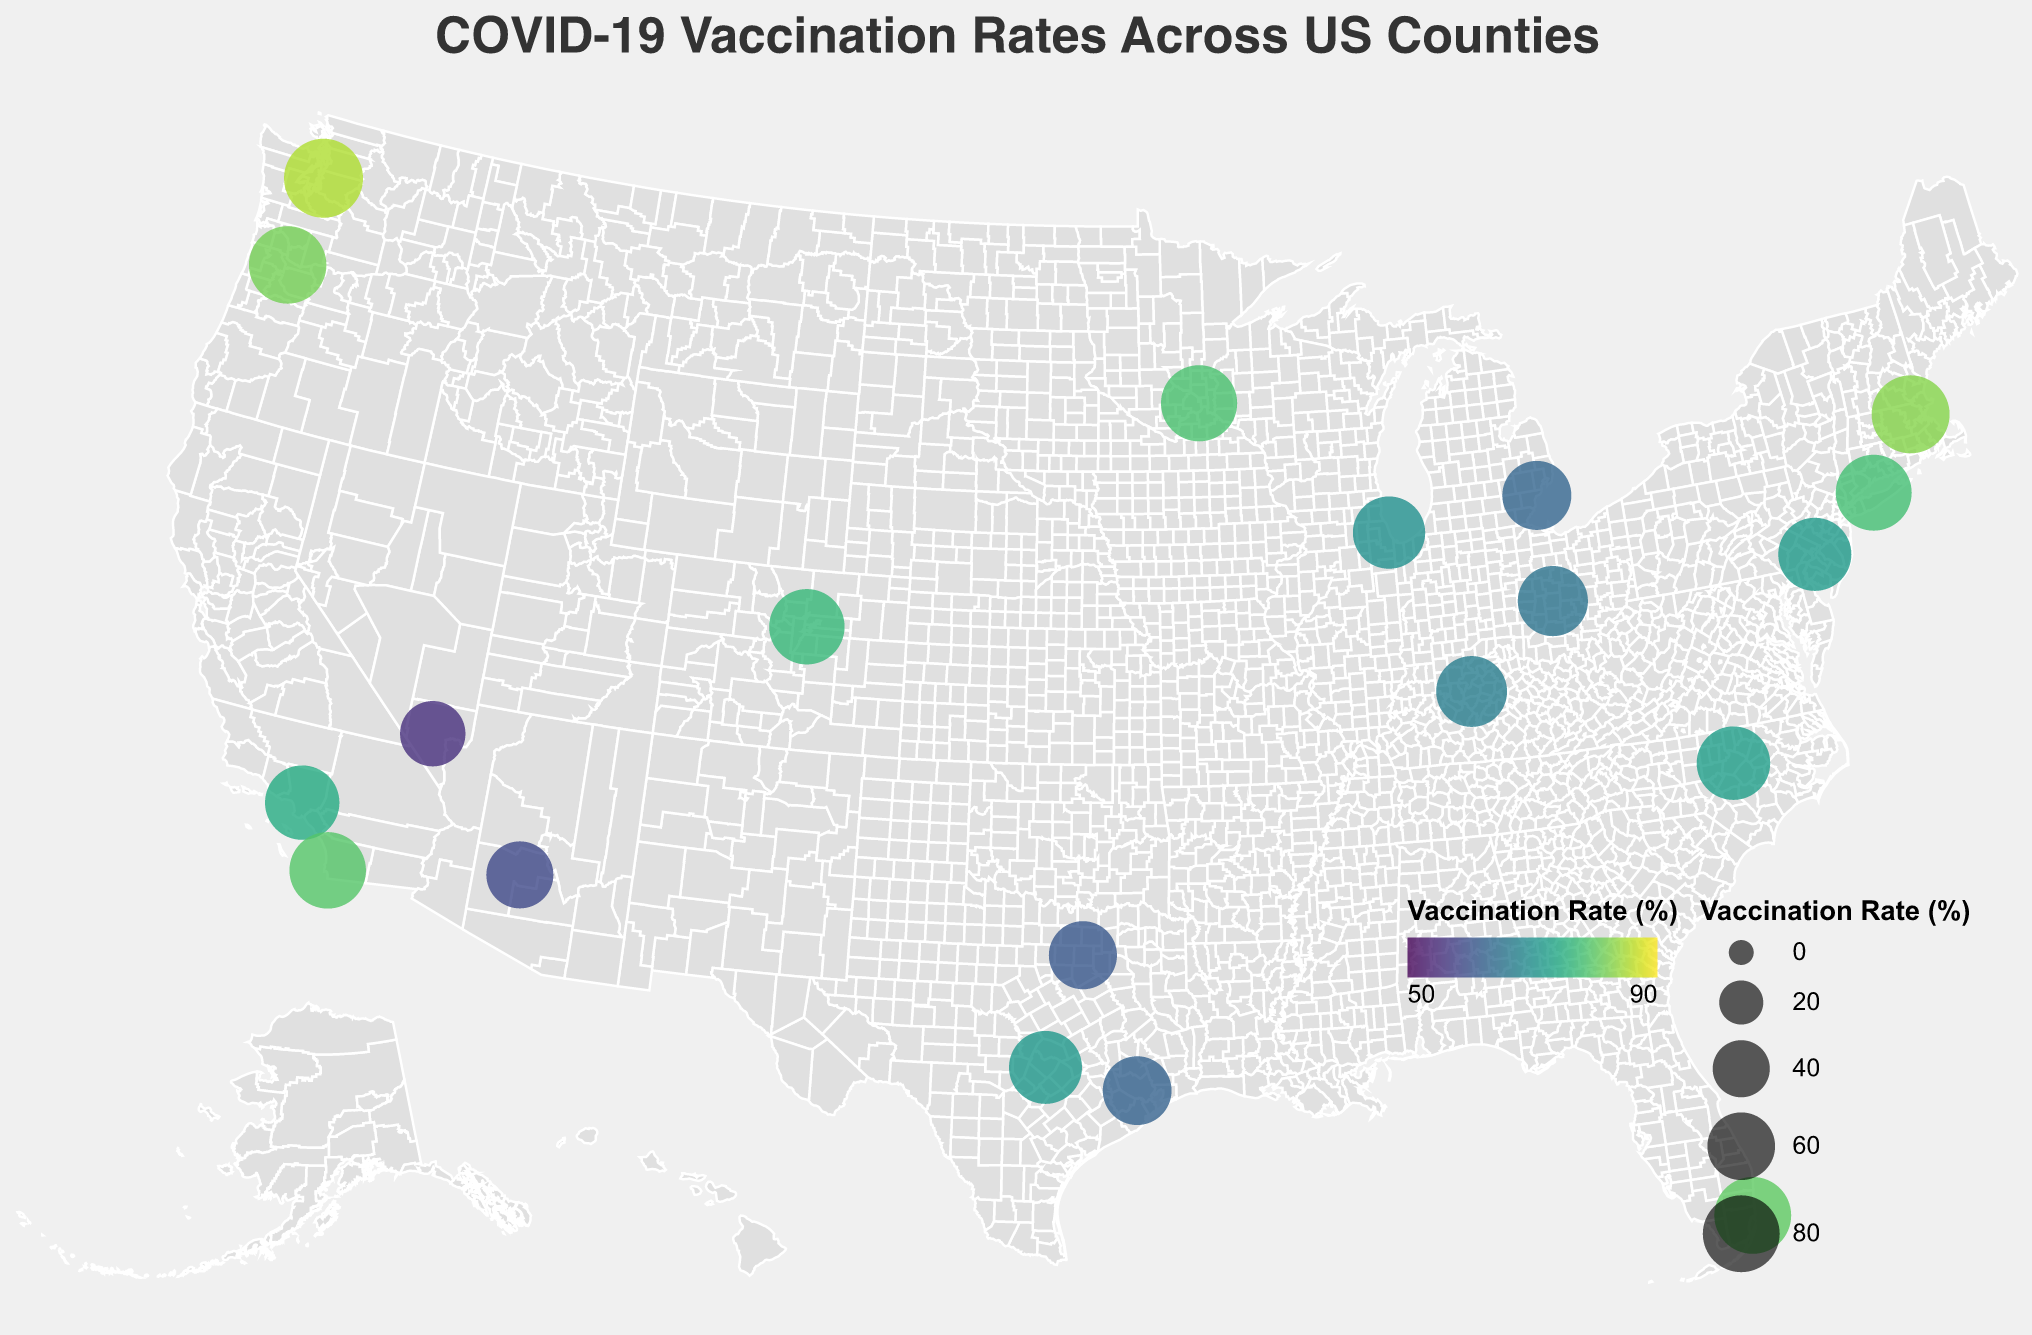What's the title of the figure? The title is usually located at the top of the figure and indicates the main subject. In this case, it is "COVID-19 Vaccination Rates Across US Counties."
Answer: COVID-19 Vaccination Rates Across US Counties Which county has the highest vaccination rate and what is it? By examining the circle sizes and colors, King County in Washington has the largest circle and the darkest color, representing the highest vaccination rate of 85.2%.
Answer: King County, 85.2% What is the vaccination rate of Los Angeles County in California? By locating Los Angeles County on the map and checking its tooltip, the vaccination rate is shown as 74.5%.
Answer: 74.5% How many counties have vaccination rates above 80%? By observing the figure, we note that the counties with darker colors have higher rates. The counties above 80% are King (85.2%), Miami-Dade (80.1%), Middlesex (82.7%), and Multnomah (81.6%).
Answer: 4 What is the vaccination rate difference between Cook County in Illinois and Dallas County in Texas? Cook County's rate is 69.8% and Dallas County's rate is 60.9%. The difference is 69.8% - 60.9% = 8.9%.
Answer: 8.9% Which state has the most counties listed in the figure? By counting the occurrence of different states, Texas has three counties listed: Harris, Dallas, and Travis.
Answer: Texas Which county has the lowest vaccination rate, and what is it? By identifying the smallest and lightest colored circle, Clark County in Nevada has the lowest rate of 55.4%.
Answer: Clark County, 55.4% Compare the vaccination rates of the counties in California. Which one is higher, and by how much? The counties listed in California are Los Angeles (74.5%) and San Diego (79.3%). San Diego's rate is higher by 79.3% - 74.5% = 4.8%.
Answer: San Diego, 4.8% What are the average vaccination rates of all counties listed? Summing the vaccination rates: (74.5 + 69.8 + 62.3 + 58.7 + 85.2 + 80.1 + 71.6 + 79.3 + 60.9 + 55.4 + 62.8 + 82.7 + 77.9 + 65.2 + 78.5 + 71.3 + 81.6 + 66.7 + 72.4 + 76.8) = 1471.7. Dividing by the number of counties (20), the average is 1471.7/20 = 73.6%.
Answer: 73.6% 